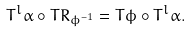Convert formula to latex. <formula><loc_0><loc_0><loc_500><loc_500>T ^ { l } \alpha \circ T R _ { \phi ^ { - 1 } } = T \phi \circ T ^ { l } \alpha .</formula> 